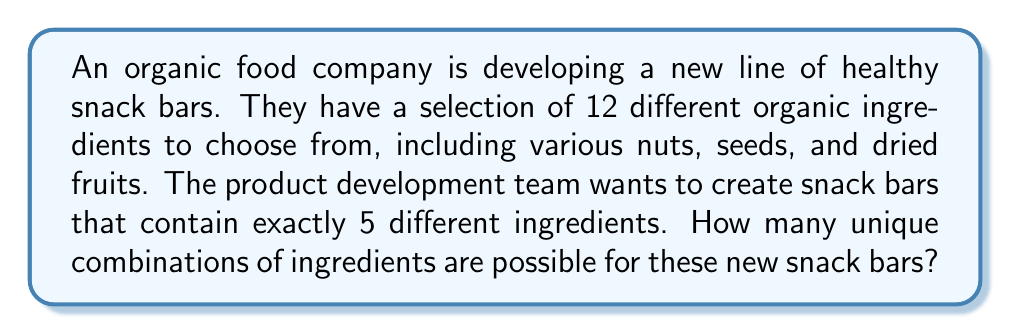What is the answer to this math problem? To solve this problem, we need to use the combination formula. We are selecting 5 ingredients from a total of 12 ingredients, where the order doesn't matter (as we're just interested in the ingredients being present, not their arrangement in the bar).

The formula for combinations is:

$$ C(n,r) = \frac{n!}{r!(n-r)!} $$

Where:
$n$ = total number of items to choose from
$r$ = number of items being chosen

In this case:
$n = 12$ (total number of ingredients)
$r = 5$ (number of ingredients in each bar)

Substituting these values into the formula:

$$ C(12,5) = \frac{12!}{5!(12-5)!} = \frac{12!}{5!(7)!} $$

Expanding this:

$$ \frac{12 \times 11 \times 10 \times 9 \times 8 \times 7!}{(5 \times 4 \times 3 \times 2 \times 1) \times 7!} $$

The 7! cancels out in the numerator and denominator:

$$ \frac{12 \times 11 \times 10 \times 9 \times 8}{5 \times 4 \times 3 \times 2 \times 1} $$

$$ = \frac{95,040}{120} = 792 $$

Therefore, there are 792 possible unique combinations of 5 ingredients that can be selected from the 12 available ingredients.
Answer: 792 unique combinations 